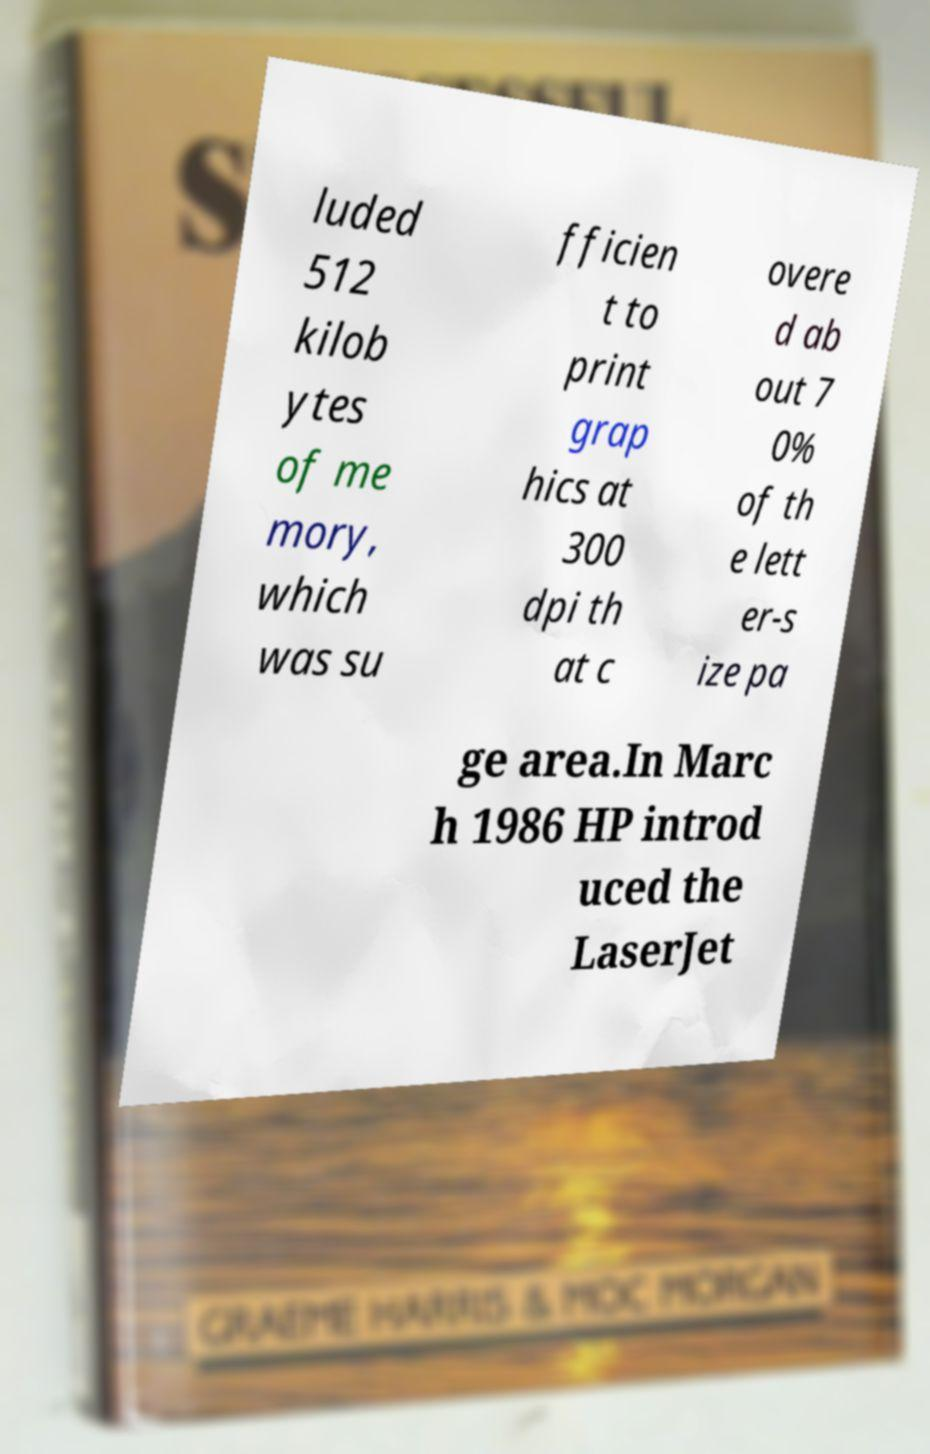What messages or text are displayed in this image? I need them in a readable, typed format. luded 512 kilob ytes of me mory, which was su fficien t to print grap hics at 300 dpi th at c overe d ab out 7 0% of th e lett er-s ize pa ge area.In Marc h 1986 HP introd uced the LaserJet 